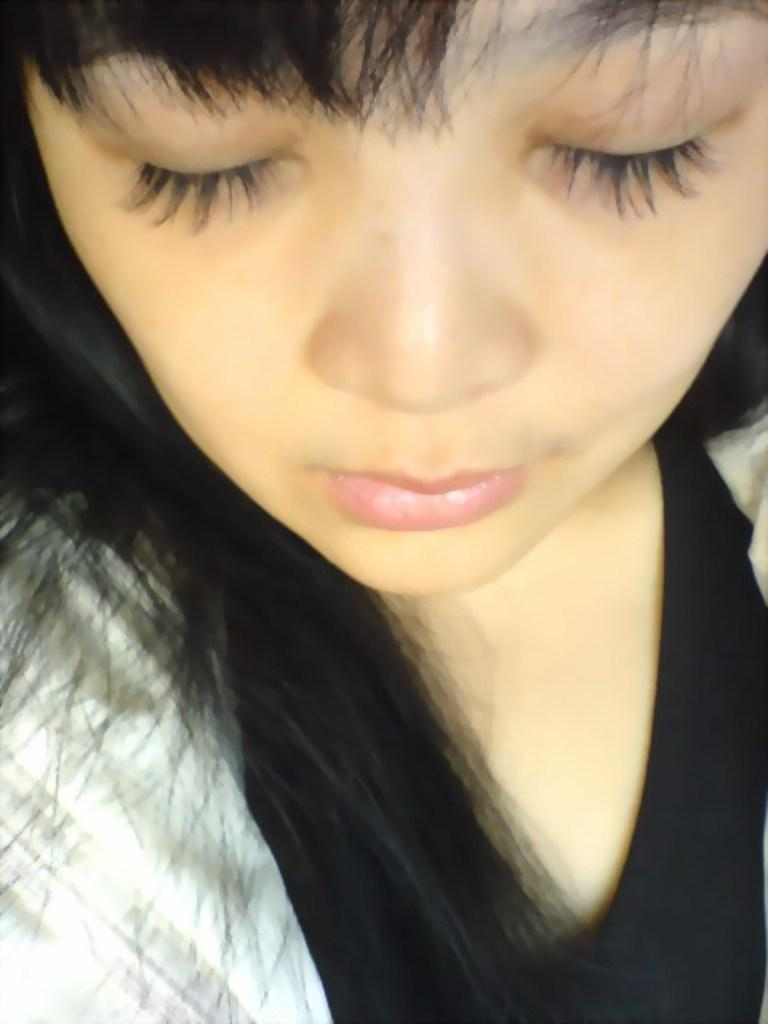Who is present in the image? There is a woman in the image. What type of feather can be seen on the sofa in the image? There is no sofa or feather present in the image; it only features a woman. 